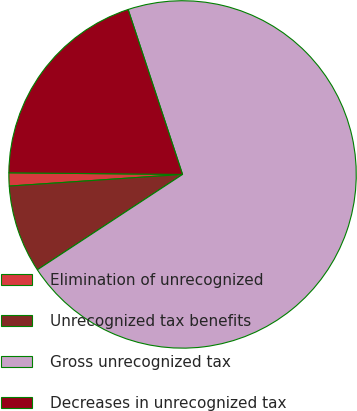Convert chart to OTSL. <chart><loc_0><loc_0><loc_500><loc_500><pie_chart><fcel>Elimination of unrecognized<fcel>Unrecognized tax benefits<fcel>Gross unrecognized tax<fcel>Decreases in unrecognized tax<nl><fcel>1.22%<fcel>8.18%<fcel>70.83%<fcel>19.78%<nl></chart> 